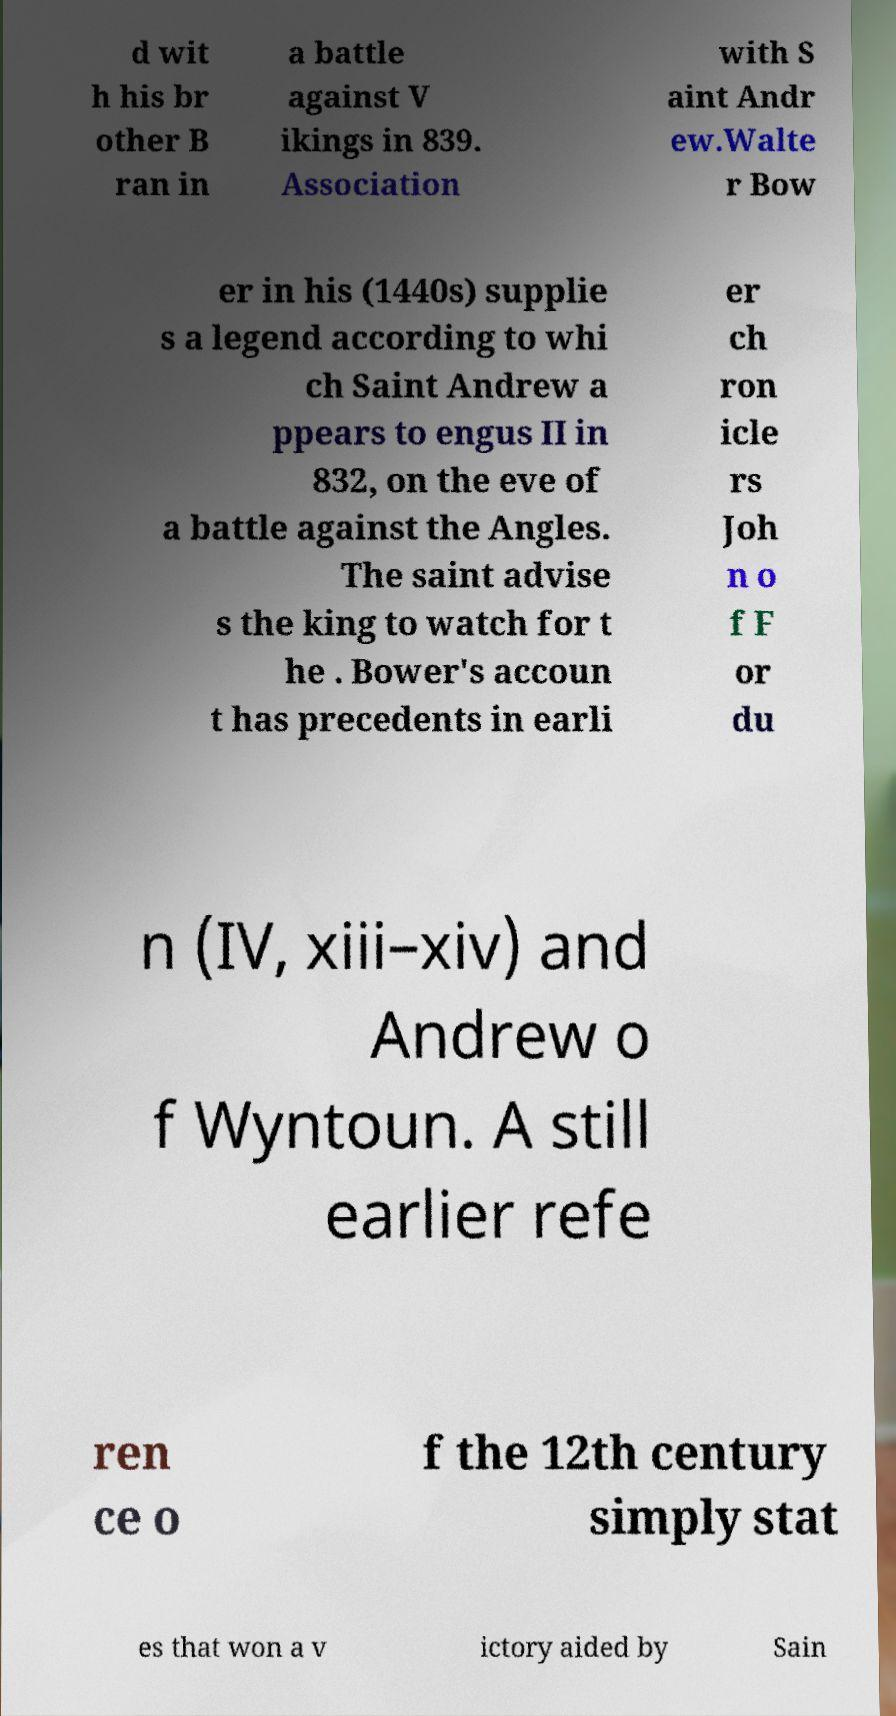Please read and relay the text visible in this image. What does it say? d wit h his br other B ran in a battle against V ikings in 839. Association with S aint Andr ew.Walte r Bow er in his (1440s) supplie s a legend according to whi ch Saint Andrew a ppears to engus II in 832, on the eve of a battle against the Angles. The saint advise s the king to watch for t he . Bower's accoun t has precedents in earli er ch ron icle rs Joh n o f F or du n (IV, xiii–xiv) and Andrew o f Wyntoun. A still earlier refe ren ce o f the 12th century simply stat es that won a v ictory aided by Sain 